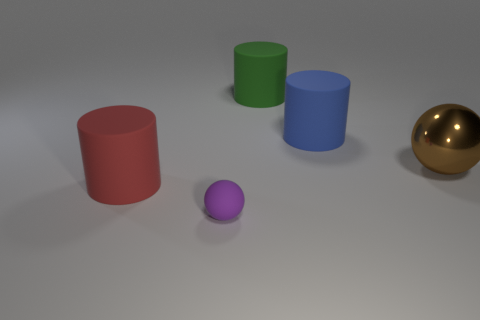The tiny matte thing has what color?
Make the answer very short. Purple. What is the color of the large object that is the same shape as the tiny matte object?
Your answer should be compact. Brown. How many other big rubber objects are the same shape as the blue object?
Your answer should be very brief. 2. How many objects are big blue cylinders or red matte cylinders in front of the green rubber thing?
Give a very brief answer. 2. There is a small rubber object; is it the same color as the big matte thing in front of the large brown metallic thing?
Give a very brief answer. No. There is a object that is both in front of the large brown object and to the right of the red cylinder; what size is it?
Your answer should be compact. Small. There is a green object; are there any large green matte things to the right of it?
Offer a very short reply. No. There is a sphere in front of the large red object; are there any red rubber objects in front of it?
Provide a succinct answer. No. Is the number of balls that are in front of the large brown metallic object the same as the number of large blue rubber cylinders in front of the purple object?
Provide a succinct answer. No. There is a tiny object that is made of the same material as the big green thing; what is its color?
Give a very brief answer. Purple. 